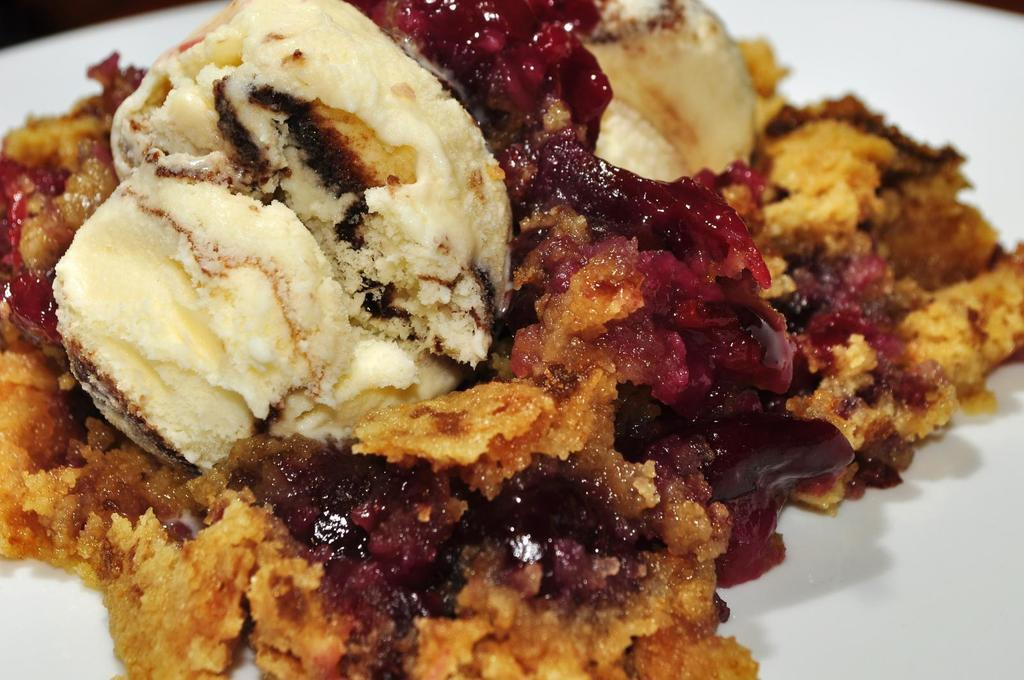What is present on the plate in the image? There is a food item on the plate in the image. Can you describe the plate in the image? The plate is visible in the image, but there is no specific description provided. What type of spacecraft can be seen in the image? There is no spacecraft present in the image; it features a plate with a food item on it. What is the point of the image? The point of the image is to show a plate with a food item on it, but there is no deeper meaning or purpose implied. 